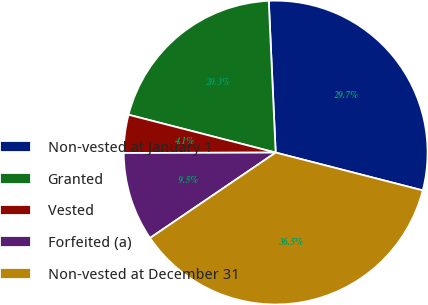Convert chart. <chart><loc_0><loc_0><loc_500><loc_500><pie_chart><fcel>Non-vested at January 1<fcel>Granted<fcel>Vested<fcel>Forfeited (a)<fcel>Non-vested at December 31<nl><fcel>29.73%<fcel>20.27%<fcel>4.05%<fcel>9.46%<fcel>36.49%<nl></chart> 